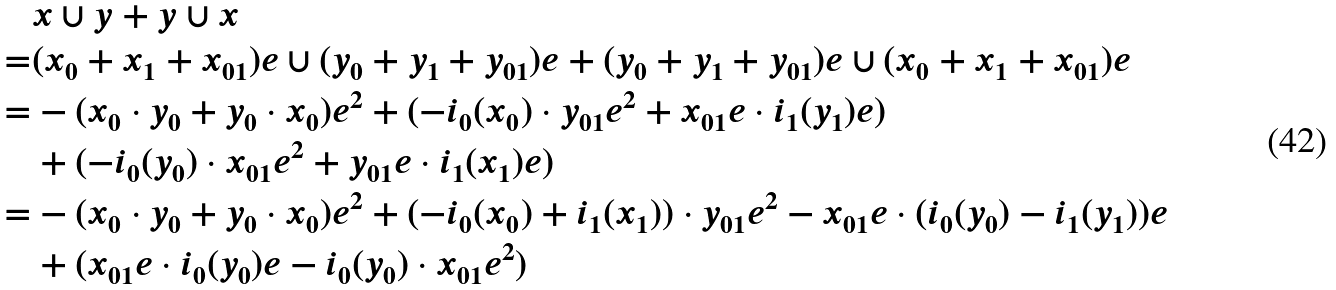Convert formula to latex. <formula><loc_0><loc_0><loc_500><loc_500>& x \cup y + y \cup x \\ = & ( x _ { 0 } + x _ { 1 } + x _ { 0 1 } ) e \cup ( y _ { 0 } + y _ { 1 } + y _ { 0 1 } ) e + ( y _ { 0 } + y _ { 1 } + y _ { 0 1 } ) e \cup ( x _ { 0 } + x _ { 1 } + x _ { 0 1 } ) e \\ = & - ( x _ { 0 } \cdot y _ { 0 } + y _ { 0 } \cdot x _ { 0 } ) e ^ { 2 } + ( - i _ { 0 } ( x _ { 0 } ) \cdot y _ { 0 1 } e ^ { 2 } + x _ { 0 1 } e \cdot i _ { 1 } ( y _ { 1 } ) e ) \\ & + ( - i _ { 0 } ( y _ { 0 } ) \cdot x _ { 0 1 } e ^ { 2 } + y _ { 0 1 } e \cdot i _ { 1 } ( x _ { 1 } ) e ) \\ = & - ( x _ { 0 } \cdot y _ { 0 } + y _ { 0 } \cdot x _ { 0 } ) e ^ { 2 } + ( - i _ { 0 } ( x _ { 0 } ) + i _ { 1 } ( x _ { 1 } ) ) \cdot y _ { 0 1 } e ^ { 2 } - x _ { 0 1 } e \cdot ( i _ { 0 } ( y _ { 0 } ) - i _ { 1 } ( y _ { 1 } ) ) e \\ & + ( x _ { 0 1 } e \cdot i _ { 0 } ( y _ { 0 } ) e - i _ { 0 } ( y _ { 0 } ) \cdot x _ { 0 1 } e ^ { 2 } )</formula> 